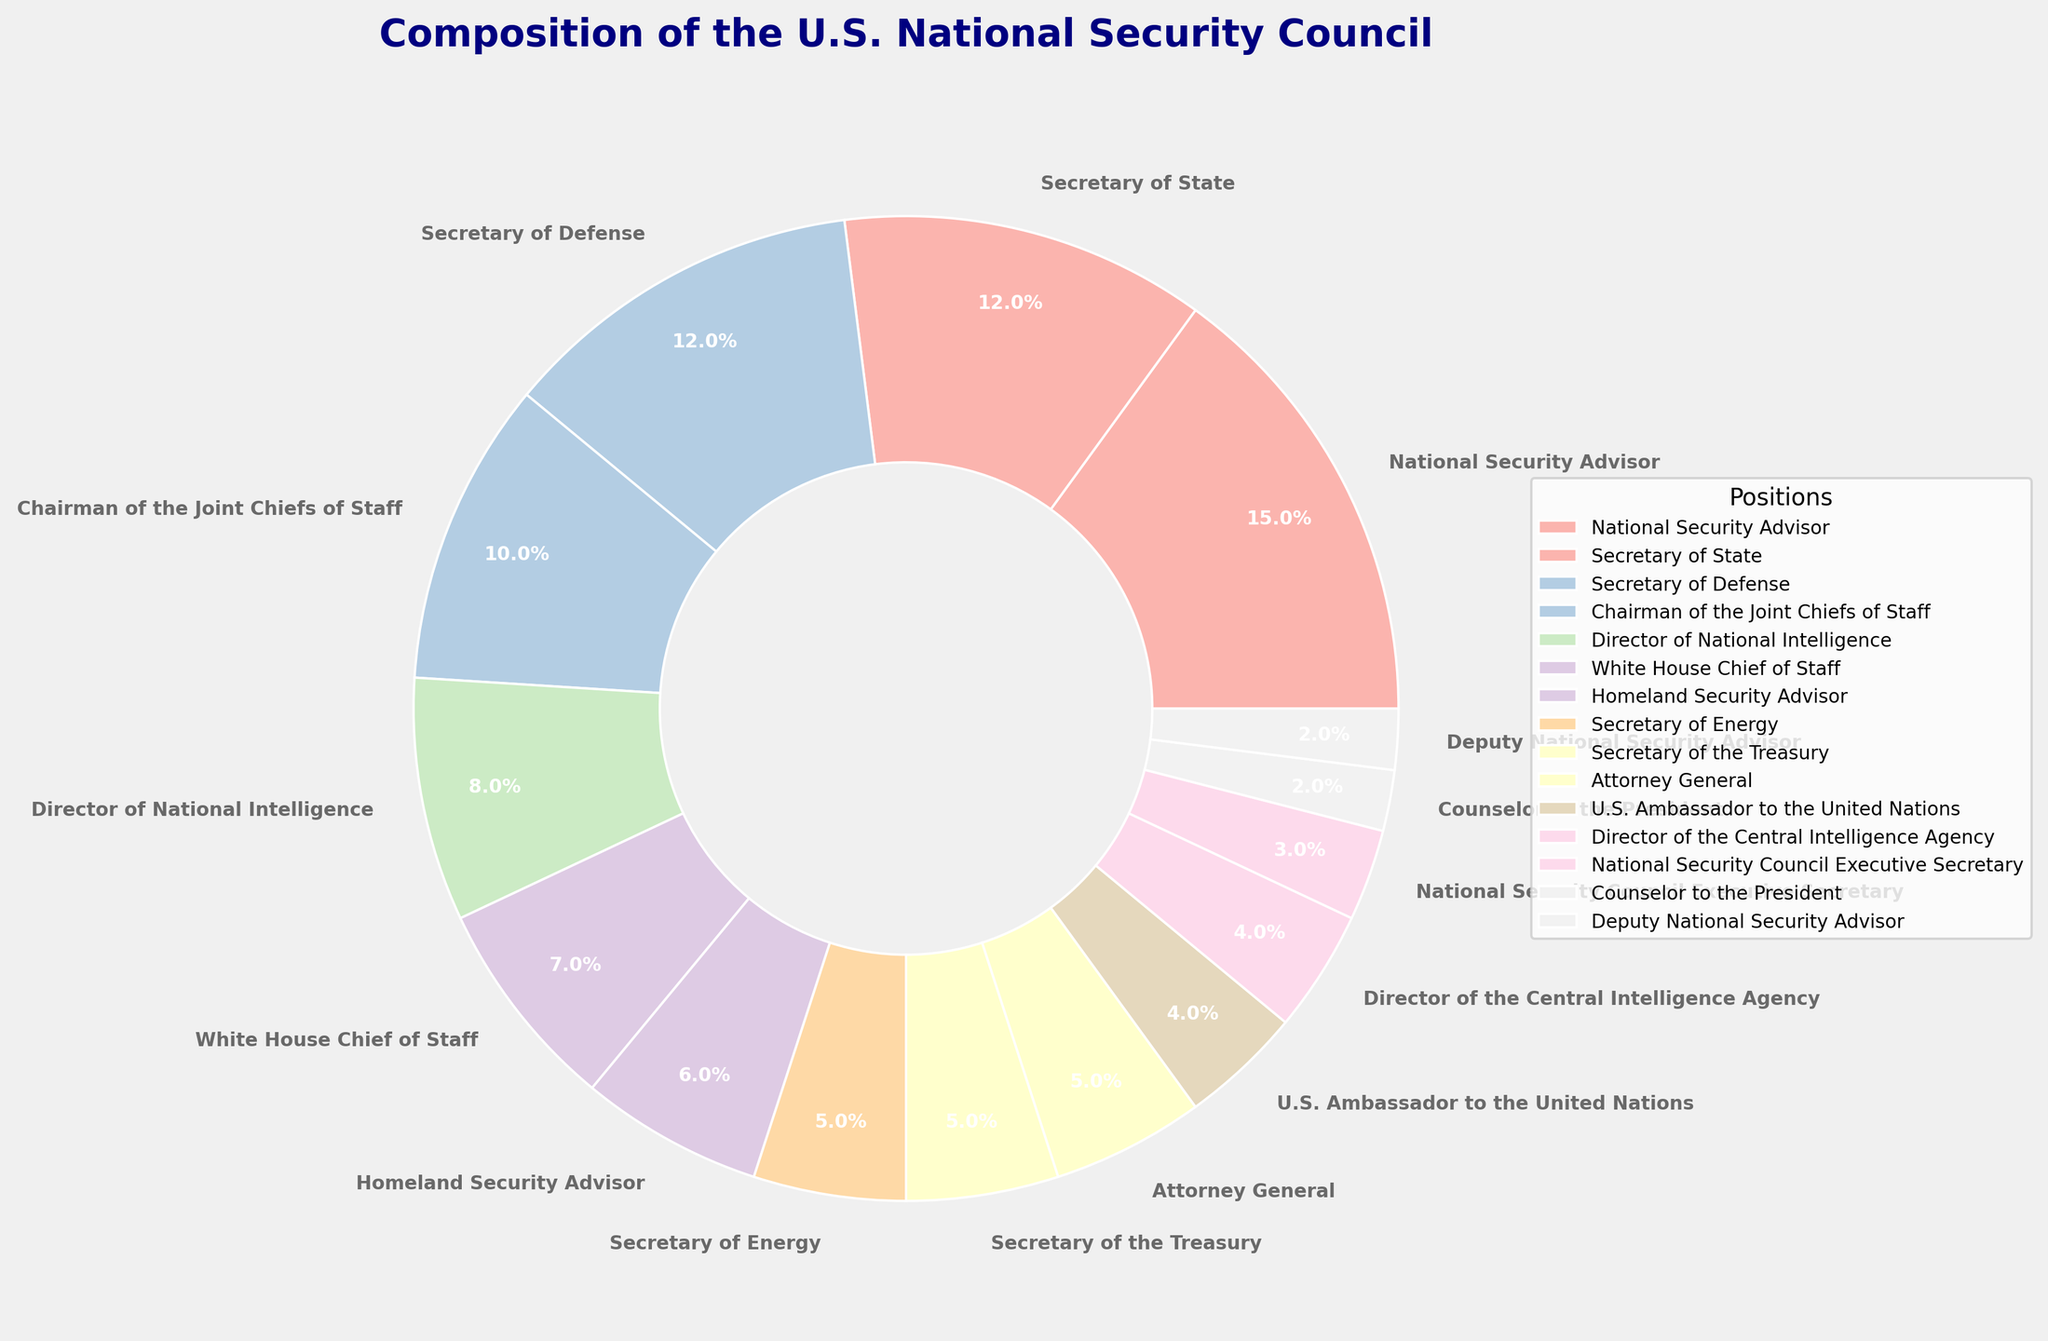What position has the highest percentage in the U.S. National Security Council composition? The pie chart shows each position's percentage clearly. The position with the largest percentage slice is the National Security Advisor.
Answer: National Security Advisor Which two positions have the same percentage of representation, and what is that percentage? By examining the chart, we can see that the Secretary of Defense and the Secretary of State both have equal-sized slices, each representing 12%.
Answer: Secretary of Defense and Secretary of State, 12% What is the combined percentage of the U.S. National Security Council held by the Secretary of Energy, Secretary of the Treasury, and Attorney General? The pie chart gives individual percentages: Secretary of Energy (5%), Secretary of the Treasury (5%), and Attorney General (5%). Adding them together, we get 5% + 5% + 5% = 15%.
Answer: 15% How much larger is the percentage of the National Security Advisor compared to the U.S. Ambassador to the United Nations? The National Security Advisor has 15%, while the U.S. Ambassador to the United Nations has 4%. Subtracting these gives 15% - 4% = 11%.
Answer: 11% What is the range of percentages represented in the pie chart? The highest percentage is 15% (National Security Advisor), and the lowest is 2% (Counselor to the President and Deputy National Security Advisor). The range is 15% - 2% = 13%.
Answer: 13% Which position is represented by the smallest percentage, and what is that percentage? Observing the smallest slices in the pie chart, both the Counselor to the President and Deputy National Security Advisor have the smallest percentages at 2%.
Answer: Counselor to the President and Deputy National Security Advisor, 2% What is the median percentage of the positions in the National Security Council? To find the median, list the percentages in ascending order: 2, 2, 3, 4, 4, 5, 5, 5, 6, 7, 8, 10, 12, 12, 15. The median of an odd set of numbers is the middle value, here the 8th value, which is 5%.
Answer: 5% By how much does the combined percentage of the Chairman of the Joint Chiefs of Staff and the Director of National Intelligence exceed the Homeland Security Advisor's percentage? The Chairman of the Joint Chiefs of Staff is 10%, and the Director of National Intelligence is 8%; combined they are 10% + 8% = 18%. The Homeland Security Advisor is 6%. The difference is 18% - 6% = 12%.
Answer: 12% Which position's percentage is closest to the average percentage of all positions? First, find the average percentage: (15 + 12 + 12 + 10 + 8 + 7 + 6 + 5 + 5 + 5 + 4 + 4 + 3 + 2 + 2) / 15 = 6.73%. The closest percentage to 6.73% is 7% (White House Chief of Staff).
Answer: White House Chief of Staff What is the percentage difference between the Secretary of State and the Counselor to the President? The Secretary of State is 12%, and the Counselor to the President is 2%. Subtracting these gives 12% - 2% = 10%.
Answer: 10% 